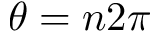<formula> <loc_0><loc_0><loc_500><loc_500>\theta = n 2 \pi</formula> 